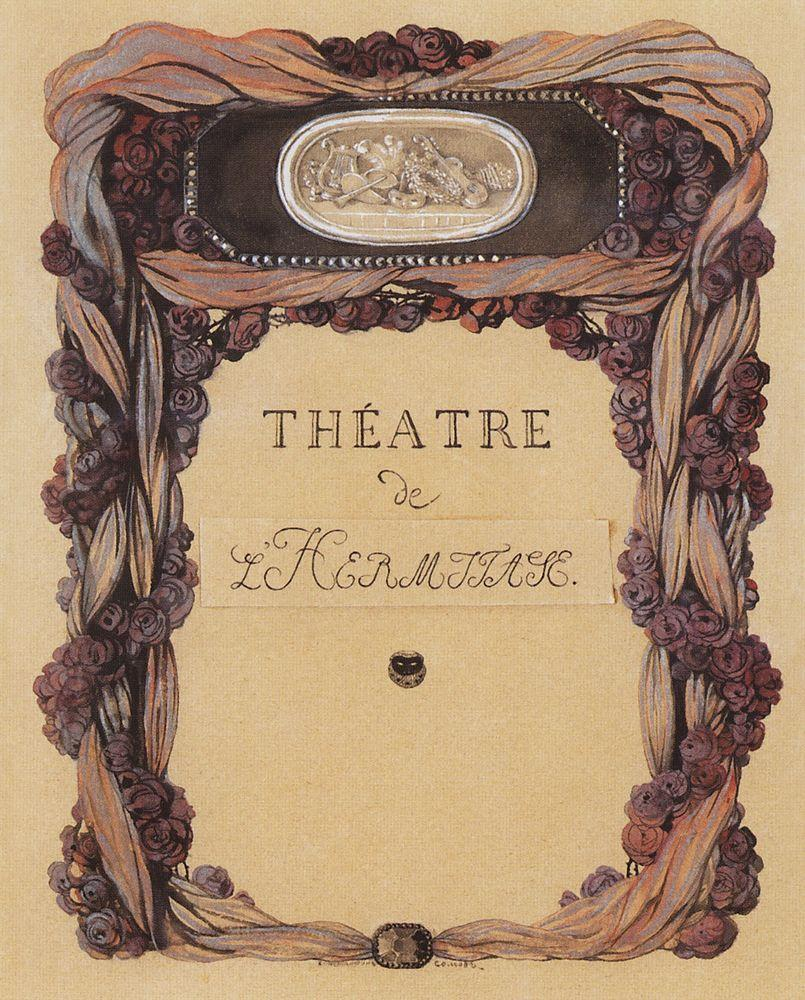Could you explain the significance of the floral elements in this Art Nouveau poster? In Art Nouveau, floral motifs are more than just decorative; they symbolize life, growth, and beauty, which are central themes of this art movement. In this poster, the roses and intertwining plants underline the natural beauty and romanticism often depicted in theatrical plays, likely reflecting the themes of the performances at 'Théâtre de L'Horloge'. These elements also create a harmonious balance around the central mirror, suggesting a window to another world, perhaps mirroring the transformative experience theater aims to provide. 